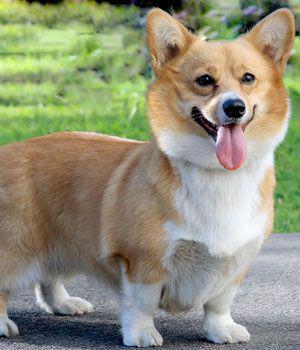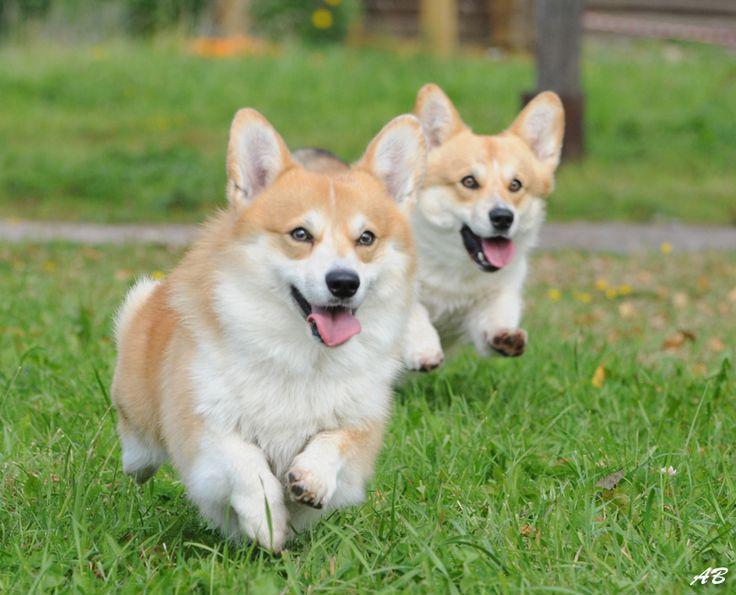The first image is the image on the left, the second image is the image on the right. Assess this claim about the two images: "At least one dog is sitting on its hind legs in the pair of images.". Correct or not? Answer yes or no. No. The first image is the image on the left, the second image is the image on the right. For the images shown, is this caption "Each image contains exactly one corgi dog, and no dog has its rear-end facing the camera." true? Answer yes or no. No. 